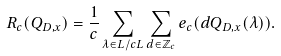Convert formula to latex. <formula><loc_0><loc_0><loc_500><loc_500>R _ { c } ( Q _ { D , x } ) = \frac { 1 } { c } \sum _ { \lambda \in L / c L } \sum _ { d \in \mathbb { Z } _ { c } } e _ { c } ( d Q _ { D , x } ( \lambda ) ) .</formula> 